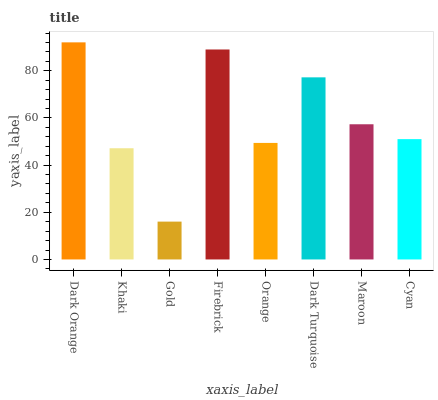Is Gold the minimum?
Answer yes or no. Yes. Is Dark Orange the maximum?
Answer yes or no. Yes. Is Khaki the minimum?
Answer yes or no. No. Is Khaki the maximum?
Answer yes or no. No. Is Dark Orange greater than Khaki?
Answer yes or no. Yes. Is Khaki less than Dark Orange?
Answer yes or no. Yes. Is Khaki greater than Dark Orange?
Answer yes or no. No. Is Dark Orange less than Khaki?
Answer yes or no. No. Is Maroon the high median?
Answer yes or no. Yes. Is Cyan the low median?
Answer yes or no. Yes. Is Dark Orange the high median?
Answer yes or no. No. Is Dark Turquoise the low median?
Answer yes or no. No. 